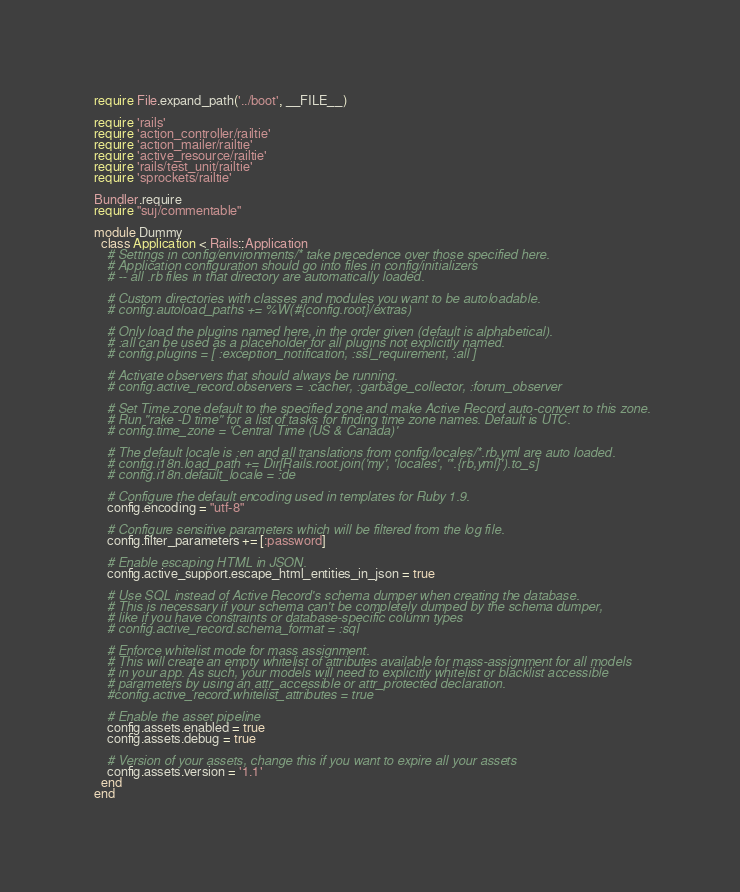Convert code to text. <code><loc_0><loc_0><loc_500><loc_500><_Ruby_>require File.expand_path('../boot', __FILE__)

require 'rails'
require 'action_controller/railtie'
require 'action_mailer/railtie'
require 'active_resource/railtie'
require 'rails/test_unit/railtie'
require 'sprockets/railtie'

Bundler.require
require "suj/commentable"

module Dummy
  class Application < Rails::Application
    # Settings in config/environments/* take precedence over those specified here.
    # Application configuration should go into files in config/initializers
    # -- all .rb files in that directory are automatically loaded.

    # Custom directories with classes and modules you want to be autoloadable.
    # config.autoload_paths += %W(#{config.root}/extras)

    # Only load the plugins named here, in the order given (default is alphabetical).
    # :all can be used as a placeholder for all plugins not explicitly named.
    # config.plugins = [ :exception_notification, :ssl_requirement, :all ]

    # Activate observers that should always be running.
    # config.active_record.observers = :cacher, :garbage_collector, :forum_observer

    # Set Time.zone default to the specified zone and make Active Record auto-convert to this zone.
    # Run "rake -D time" for a list of tasks for finding time zone names. Default is UTC.
    # config.time_zone = 'Central Time (US & Canada)'

    # The default locale is :en and all translations from config/locales/*.rb,yml are auto loaded.
    # config.i18n.load_path += Dir[Rails.root.join('my', 'locales', '*.{rb,yml}').to_s]
    # config.i18n.default_locale = :de

    # Configure the default encoding used in templates for Ruby 1.9.
    config.encoding = "utf-8"

    # Configure sensitive parameters which will be filtered from the log file.
    config.filter_parameters += [:password]

    # Enable escaping HTML in JSON.
    config.active_support.escape_html_entities_in_json = true

    # Use SQL instead of Active Record's schema dumper when creating the database.
    # This is necessary if your schema can't be completely dumped by the schema dumper,
    # like if you have constraints or database-specific column types
    # config.active_record.schema_format = :sql

    # Enforce whitelist mode for mass assignment.
    # This will create an empty whitelist of attributes available for mass-assignment for all models
    # in your app. As such, your models will need to explicitly whitelist or blacklist accessible
    # parameters by using an attr_accessible or attr_protected declaration.
    #config.active_record.whitelist_attributes = true

    # Enable the asset pipeline
    config.assets.enabled = true
    config.assets.debug = true

    # Version of your assets, change this if you want to expire all your assets
    config.assets.version = '1.1'
  end
end

</code> 